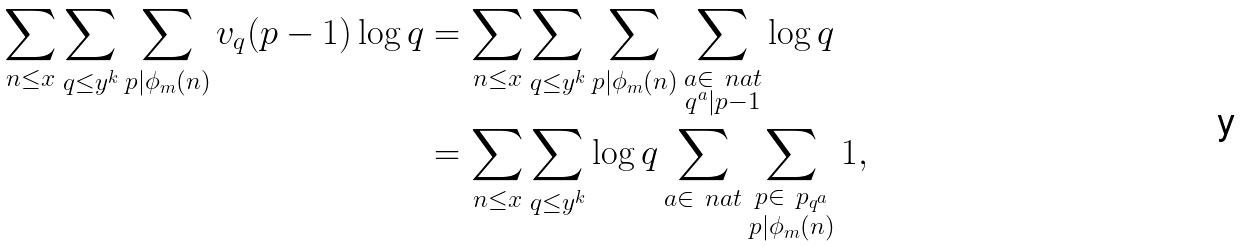<formula> <loc_0><loc_0><loc_500><loc_500>\sum _ { n \leq x } \sum _ { q \leq y ^ { k } } \sum _ { p | \phi _ { m } ( n ) } v _ { q } ( p - 1 ) \log q & = \sum _ { n \leq x } \sum _ { q \leq y ^ { k } } \sum _ { p | \phi _ { m } ( n ) } \sum _ { \substack { a \in \ n a t \\ q ^ { a } | p - 1 } } \log q \\ & = \sum _ { n \leq x } \sum _ { q \leq y ^ { k } } \log q \sum _ { a \in \ n a t } \sum _ { \substack { p \in \ p _ { q ^ { a } } \\ p | \phi _ { m } ( n ) } } 1 ,</formula> 